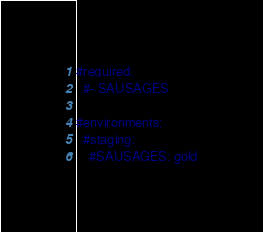Convert code to text. <code><loc_0><loc_0><loc_500><loc_500><_YAML_>#required:
  #- SAUSAGES

#environments:
  #staging:
    #SAUSAGES: gold
</code> 